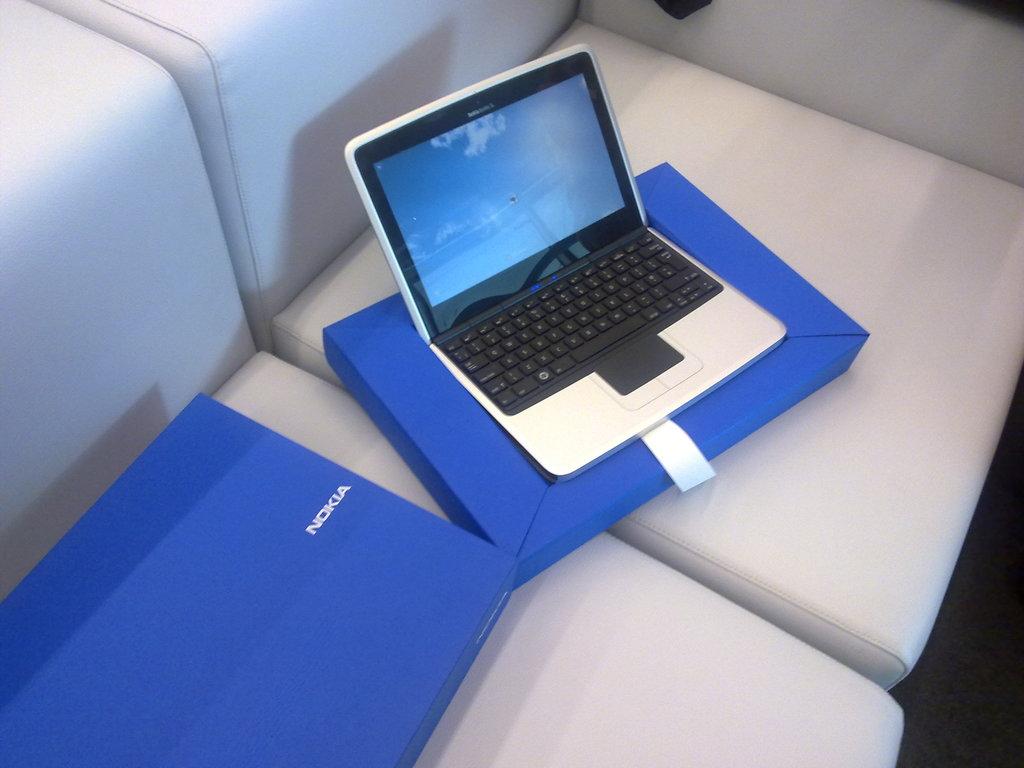What type of a device is this?
Keep it short and to the point. Nokia. What brand is this?
Offer a terse response. Nokia. 